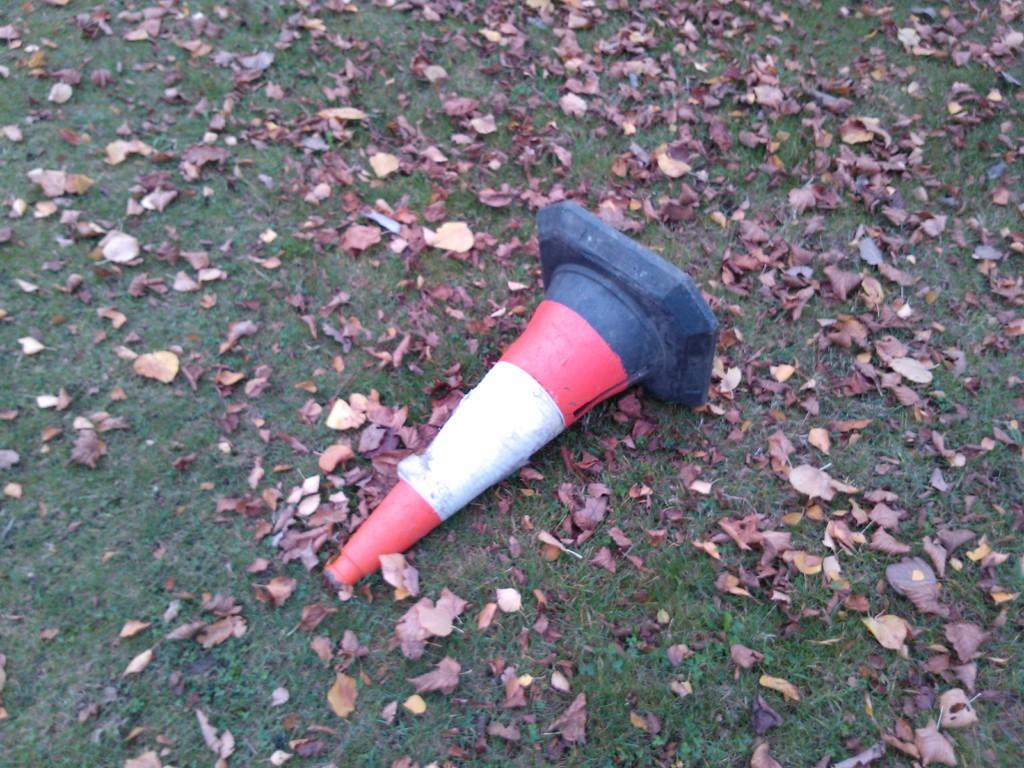What is the main object in the middle of the image? There is a traffic cone in the middle of the image. Where is the traffic cone located? The traffic cone is on the ground. What type of natural environment is visible in the image? There is grass visible in the image. What additional elements can be seen on the ground? Dry leaves are present in the image. Can you see a goldfish swimming in the image? No, there is no goldfish present in the image. What type of farewell is being expressed in the image? There is no farewell or "good-bye" being expressed in the image; it features a traffic cone, grass, and dry leaves. Is there a cat visible in the image? No, there is no cat present in the image. 